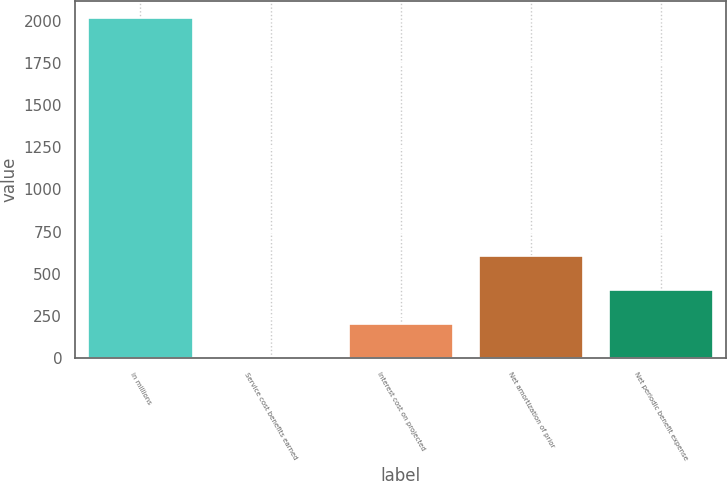Convert chart. <chart><loc_0><loc_0><loc_500><loc_500><bar_chart><fcel>in millions<fcel>Service cost benefits earned<fcel>Interest cost on projected<fcel>Net amortization of prior<fcel>Net periodic benefit expense<nl><fcel>2015<fcel>1<fcel>202.4<fcel>605.2<fcel>403.8<nl></chart> 